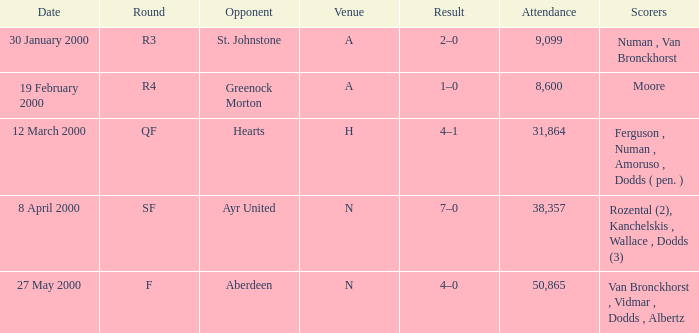Who was on 12 March 2000? Ferguson , Numan , Amoruso , Dodds ( pen. ). 